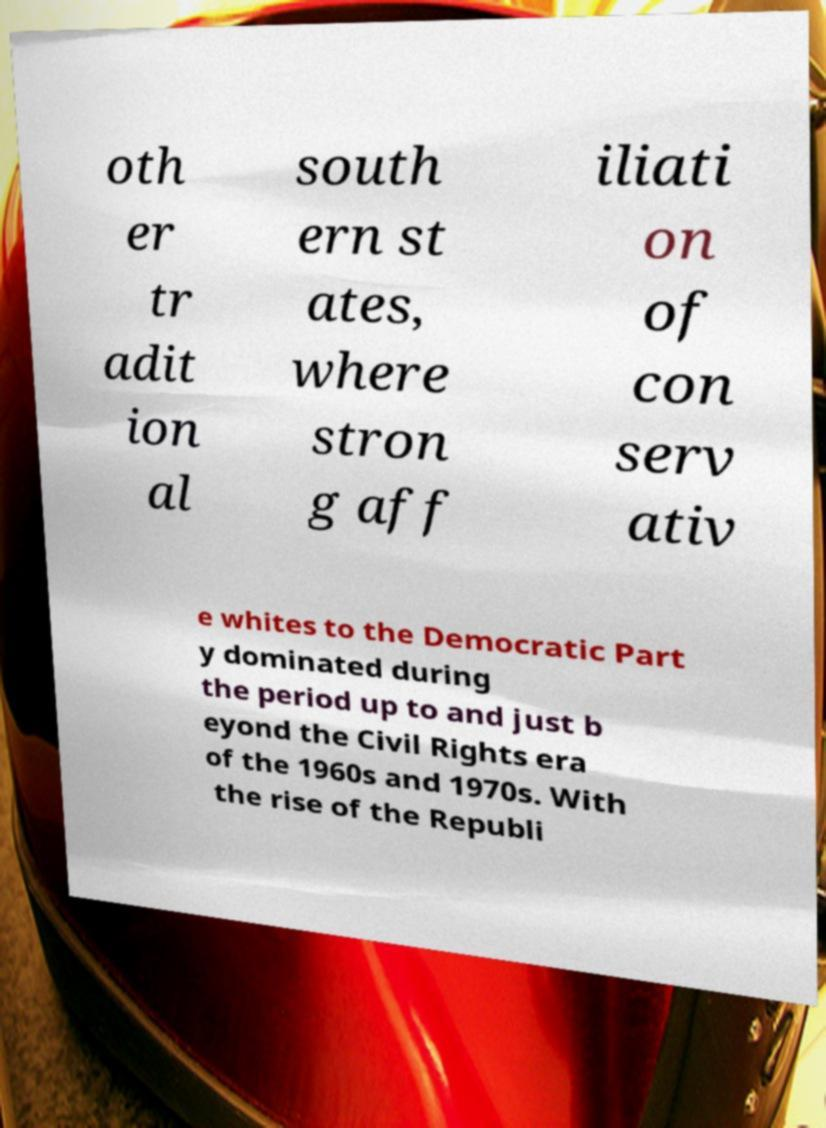For documentation purposes, I need the text within this image transcribed. Could you provide that? oth er tr adit ion al south ern st ates, where stron g aff iliati on of con serv ativ e whites to the Democratic Part y dominated during the period up to and just b eyond the Civil Rights era of the 1960s and 1970s. With the rise of the Republi 